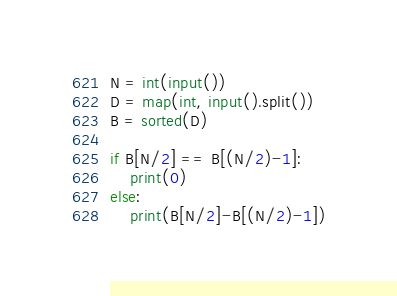<code> <loc_0><loc_0><loc_500><loc_500><_Python_>N = int(input())
D = map(int, input().split())
B = sorted(D)

if B[N/2] == B[(N/2)-1]:
    print(0)
else:
    print(B[N/2]-B[(N/2)-1])</code> 